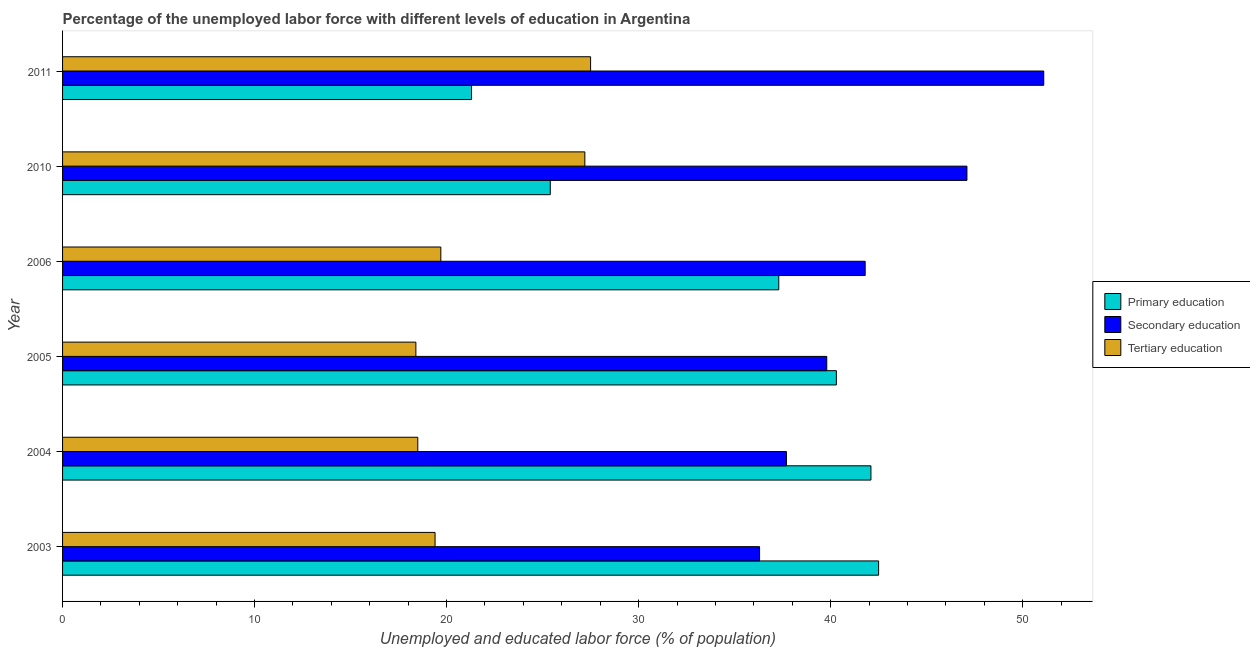How many different coloured bars are there?
Your answer should be very brief. 3. How many groups of bars are there?
Ensure brevity in your answer.  6. Are the number of bars per tick equal to the number of legend labels?
Provide a succinct answer. Yes. How many bars are there on the 5th tick from the top?
Offer a very short reply. 3. How many bars are there on the 3rd tick from the bottom?
Offer a terse response. 3. What is the label of the 4th group of bars from the top?
Make the answer very short. 2005. In how many cases, is the number of bars for a given year not equal to the number of legend labels?
Keep it short and to the point. 0. What is the percentage of labor force who received secondary education in 2005?
Your response must be concise. 39.8. Across all years, what is the maximum percentage of labor force who received secondary education?
Keep it short and to the point. 51.1. Across all years, what is the minimum percentage of labor force who received primary education?
Your response must be concise. 21.3. In which year was the percentage of labor force who received tertiary education maximum?
Ensure brevity in your answer.  2011. What is the total percentage of labor force who received tertiary education in the graph?
Your answer should be compact. 130.7. What is the difference between the percentage of labor force who received primary education in 2010 and that in 2011?
Your answer should be compact. 4.1. What is the difference between the percentage of labor force who received tertiary education in 2011 and the percentage of labor force who received secondary education in 2010?
Offer a terse response. -19.6. What is the average percentage of labor force who received primary education per year?
Your answer should be compact. 34.82. In the year 2005, what is the difference between the percentage of labor force who received primary education and percentage of labor force who received tertiary education?
Offer a terse response. 21.9. What is the ratio of the percentage of labor force who received primary education in 2004 to that in 2006?
Offer a very short reply. 1.13. Is the difference between the percentage of labor force who received secondary education in 2003 and 2004 greater than the difference between the percentage of labor force who received primary education in 2003 and 2004?
Ensure brevity in your answer.  No. What does the 2nd bar from the bottom in 2010 represents?
Your response must be concise. Secondary education. How many bars are there?
Provide a short and direct response. 18. Are all the bars in the graph horizontal?
Make the answer very short. Yes. What is the difference between two consecutive major ticks on the X-axis?
Provide a short and direct response. 10. Are the values on the major ticks of X-axis written in scientific E-notation?
Offer a very short reply. No. Does the graph contain grids?
Give a very brief answer. No. What is the title of the graph?
Make the answer very short. Percentage of the unemployed labor force with different levels of education in Argentina. What is the label or title of the X-axis?
Offer a terse response. Unemployed and educated labor force (% of population). What is the Unemployed and educated labor force (% of population) of Primary education in 2003?
Provide a succinct answer. 42.5. What is the Unemployed and educated labor force (% of population) in Secondary education in 2003?
Offer a terse response. 36.3. What is the Unemployed and educated labor force (% of population) in Tertiary education in 2003?
Give a very brief answer. 19.4. What is the Unemployed and educated labor force (% of population) of Primary education in 2004?
Your answer should be compact. 42.1. What is the Unemployed and educated labor force (% of population) of Secondary education in 2004?
Give a very brief answer. 37.7. What is the Unemployed and educated labor force (% of population) of Primary education in 2005?
Your answer should be compact. 40.3. What is the Unemployed and educated labor force (% of population) of Secondary education in 2005?
Give a very brief answer. 39.8. What is the Unemployed and educated labor force (% of population) of Tertiary education in 2005?
Your response must be concise. 18.4. What is the Unemployed and educated labor force (% of population) in Primary education in 2006?
Offer a very short reply. 37.3. What is the Unemployed and educated labor force (% of population) of Secondary education in 2006?
Your answer should be very brief. 41.8. What is the Unemployed and educated labor force (% of population) of Tertiary education in 2006?
Provide a succinct answer. 19.7. What is the Unemployed and educated labor force (% of population) in Primary education in 2010?
Offer a very short reply. 25.4. What is the Unemployed and educated labor force (% of population) of Secondary education in 2010?
Make the answer very short. 47.1. What is the Unemployed and educated labor force (% of population) in Tertiary education in 2010?
Your response must be concise. 27.2. What is the Unemployed and educated labor force (% of population) in Primary education in 2011?
Your answer should be very brief. 21.3. What is the Unemployed and educated labor force (% of population) in Secondary education in 2011?
Make the answer very short. 51.1. Across all years, what is the maximum Unemployed and educated labor force (% of population) in Primary education?
Give a very brief answer. 42.5. Across all years, what is the maximum Unemployed and educated labor force (% of population) of Secondary education?
Your answer should be very brief. 51.1. Across all years, what is the minimum Unemployed and educated labor force (% of population) of Primary education?
Your response must be concise. 21.3. Across all years, what is the minimum Unemployed and educated labor force (% of population) in Secondary education?
Offer a terse response. 36.3. Across all years, what is the minimum Unemployed and educated labor force (% of population) in Tertiary education?
Make the answer very short. 18.4. What is the total Unemployed and educated labor force (% of population) of Primary education in the graph?
Keep it short and to the point. 208.9. What is the total Unemployed and educated labor force (% of population) in Secondary education in the graph?
Your answer should be very brief. 253.8. What is the total Unemployed and educated labor force (% of population) of Tertiary education in the graph?
Ensure brevity in your answer.  130.7. What is the difference between the Unemployed and educated labor force (% of population) of Primary education in 2003 and that in 2004?
Your response must be concise. 0.4. What is the difference between the Unemployed and educated labor force (% of population) of Secondary education in 2003 and that in 2004?
Keep it short and to the point. -1.4. What is the difference between the Unemployed and educated labor force (% of population) in Primary education in 2003 and that in 2005?
Ensure brevity in your answer.  2.2. What is the difference between the Unemployed and educated labor force (% of population) of Secondary education in 2003 and that in 2005?
Make the answer very short. -3.5. What is the difference between the Unemployed and educated labor force (% of population) in Tertiary education in 2003 and that in 2005?
Offer a very short reply. 1. What is the difference between the Unemployed and educated labor force (% of population) in Primary education in 2003 and that in 2006?
Your answer should be compact. 5.2. What is the difference between the Unemployed and educated labor force (% of population) in Secondary education in 2003 and that in 2006?
Ensure brevity in your answer.  -5.5. What is the difference between the Unemployed and educated labor force (% of population) of Secondary education in 2003 and that in 2010?
Your answer should be very brief. -10.8. What is the difference between the Unemployed and educated labor force (% of population) in Tertiary education in 2003 and that in 2010?
Make the answer very short. -7.8. What is the difference between the Unemployed and educated labor force (% of population) in Primary education in 2003 and that in 2011?
Provide a succinct answer. 21.2. What is the difference between the Unemployed and educated labor force (% of population) in Secondary education in 2003 and that in 2011?
Your answer should be compact. -14.8. What is the difference between the Unemployed and educated labor force (% of population) in Tertiary education in 2003 and that in 2011?
Your response must be concise. -8.1. What is the difference between the Unemployed and educated labor force (% of population) in Secondary education in 2004 and that in 2005?
Keep it short and to the point. -2.1. What is the difference between the Unemployed and educated labor force (% of population) in Tertiary education in 2004 and that in 2006?
Give a very brief answer. -1.2. What is the difference between the Unemployed and educated labor force (% of population) of Primary education in 2004 and that in 2011?
Ensure brevity in your answer.  20.8. What is the difference between the Unemployed and educated labor force (% of population) of Primary education in 2005 and that in 2006?
Give a very brief answer. 3. What is the difference between the Unemployed and educated labor force (% of population) in Secondary education in 2005 and that in 2006?
Make the answer very short. -2. What is the difference between the Unemployed and educated labor force (% of population) of Tertiary education in 2005 and that in 2010?
Provide a succinct answer. -8.8. What is the difference between the Unemployed and educated labor force (% of population) of Tertiary education in 2006 and that in 2010?
Keep it short and to the point. -7.5. What is the difference between the Unemployed and educated labor force (% of population) of Tertiary education in 2006 and that in 2011?
Provide a succinct answer. -7.8. What is the difference between the Unemployed and educated labor force (% of population) in Primary education in 2003 and the Unemployed and educated labor force (% of population) in Tertiary education in 2004?
Give a very brief answer. 24. What is the difference between the Unemployed and educated labor force (% of population) in Primary education in 2003 and the Unemployed and educated labor force (% of population) in Tertiary education in 2005?
Offer a terse response. 24.1. What is the difference between the Unemployed and educated labor force (% of population) of Secondary education in 2003 and the Unemployed and educated labor force (% of population) of Tertiary education in 2005?
Give a very brief answer. 17.9. What is the difference between the Unemployed and educated labor force (% of population) of Primary education in 2003 and the Unemployed and educated labor force (% of population) of Tertiary education in 2006?
Ensure brevity in your answer.  22.8. What is the difference between the Unemployed and educated labor force (% of population) in Secondary education in 2003 and the Unemployed and educated labor force (% of population) in Tertiary education in 2006?
Ensure brevity in your answer.  16.6. What is the difference between the Unemployed and educated labor force (% of population) of Primary education in 2003 and the Unemployed and educated labor force (% of population) of Secondary education in 2010?
Provide a short and direct response. -4.6. What is the difference between the Unemployed and educated labor force (% of population) in Primary education in 2003 and the Unemployed and educated labor force (% of population) in Tertiary education in 2010?
Your answer should be compact. 15.3. What is the difference between the Unemployed and educated labor force (% of population) of Secondary education in 2003 and the Unemployed and educated labor force (% of population) of Tertiary education in 2011?
Give a very brief answer. 8.8. What is the difference between the Unemployed and educated labor force (% of population) in Primary education in 2004 and the Unemployed and educated labor force (% of population) in Tertiary education in 2005?
Your answer should be very brief. 23.7. What is the difference between the Unemployed and educated labor force (% of population) in Secondary education in 2004 and the Unemployed and educated labor force (% of population) in Tertiary education in 2005?
Provide a short and direct response. 19.3. What is the difference between the Unemployed and educated labor force (% of population) in Primary education in 2004 and the Unemployed and educated labor force (% of population) in Secondary education in 2006?
Your answer should be very brief. 0.3. What is the difference between the Unemployed and educated labor force (% of population) in Primary education in 2004 and the Unemployed and educated labor force (% of population) in Tertiary education in 2006?
Provide a short and direct response. 22.4. What is the difference between the Unemployed and educated labor force (% of population) in Secondary education in 2004 and the Unemployed and educated labor force (% of population) in Tertiary education in 2006?
Offer a terse response. 18. What is the difference between the Unemployed and educated labor force (% of population) of Primary education in 2004 and the Unemployed and educated labor force (% of population) of Tertiary education in 2011?
Give a very brief answer. 14.6. What is the difference between the Unemployed and educated labor force (% of population) of Primary education in 2005 and the Unemployed and educated labor force (% of population) of Tertiary education in 2006?
Your answer should be very brief. 20.6. What is the difference between the Unemployed and educated labor force (% of population) in Secondary education in 2005 and the Unemployed and educated labor force (% of population) in Tertiary education in 2006?
Your response must be concise. 20.1. What is the difference between the Unemployed and educated labor force (% of population) of Primary education in 2005 and the Unemployed and educated labor force (% of population) of Secondary education in 2010?
Keep it short and to the point. -6.8. What is the difference between the Unemployed and educated labor force (% of population) in Secondary education in 2005 and the Unemployed and educated labor force (% of population) in Tertiary education in 2010?
Provide a succinct answer. 12.6. What is the difference between the Unemployed and educated labor force (% of population) in Primary education in 2005 and the Unemployed and educated labor force (% of population) in Secondary education in 2011?
Provide a short and direct response. -10.8. What is the difference between the Unemployed and educated labor force (% of population) of Primary education in 2005 and the Unemployed and educated labor force (% of population) of Tertiary education in 2011?
Ensure brevity in your answer.  12.8. What is the difference between the Unemployed and educated labor force (% of population) of Secondary education in 2005 and the Unemployed and educated labor force (% of population) of Tertiary education in 2011?
Your answer should be very brief. 12.3. What is the difference between the Unemployed and educated labor force (% of population) of Primary education in 2006 and the Unemployed and educated labor force (% of population) of Tertiary education in 2010?
Offer a very short reply. 10.1. What is the difference between the Unemployed and educated labor force (% of population) in Primary education in 2006 and the Unemployed and educated labor force (% of population) in Secondary education in 2011?
Your response must be concise. -13.8. What is the difference between the Unemployed and educated labor force (% of population) in Primary education in 2006 and the Unemployed and educated labor force (% of population) in Tertiary education in 2011?
Offer a very short reply. 9.8. What is the difference between the Unemployed and educated labor force (% of population) of Primary education in 2010 and the Unemployed and educated labor force (% of population) of Secondary education in 2011?
Make the answer very short. -25.7. What is the difference between the Unemployed and educated labor force (% of population) in Primary education in 2010 and the Unemployed and educated labor force (% of population) in Tertiary education in 2011?
Make the answer very short. -2.1. What is the difference between the Unemployed and educated labor force (% of population) in Secondary education in 2010 and the Unemployed and educated labor force (% of population) in Tertiary education in 2011?
Ensure brevity in your answer.  19.6. What is the average Unemployed and educated labor force (% of population) of Primary education per year?
Offer a terse response. 34.82. What is the average Unemployed and educated labor force (% of population) in Secondary education per year?
Offer a very short reply. 42.3. What is the average Unemployed and educated labor force (% of population) in Tertiary education per year?
Your answer should be very brief. 21.78. In the year 2003, what is the difference between the Unemployed and educated labor force (% of population) of Primary education and Unemployed and educated labor force (% of population) of Tertiary education?
Your answer should be compact. 23.1. In the year 2003, what is the difference between the Unemployed and educated labor force (% of population) of Secondary education and Unemployed and educated labor force (% of population) of Tertiary education?
Offer a very short reply. 16.9. In the year 2004, what is the difference between the Unemployed and educated labor force (% of population) in Primary education and Unemployed and educated labor force (% of population) in Secondary education?
Make the answer very short. 4.4. In the year 2004, what is the difference between the Unemployed and educated labor force (% of population) in Primary education and Unemployed and educated labor force (% of population) in Tertiary education?
Provide a succinct answer. 23.6. In the year 2005, what is the difference between the Unemployed and educated labor force (% of population) of Primary education and Unemployed and educated labor force (% of population) of Secondary education?
Keep it short and to the point. 0.5. In the year 2005, what is the difference between the Unemployed and educated labor force (% of population) in Primary education and Unemployed and educated labor force (% of population) in Tertiary education?
Ensure brevity in your answer.  21.9. In the year 2005, what is the difference between the Unemployed and educated labor force (% of population) in Secondary education and Unemployed and educated labor force (% of population) in Tertiary education?
Provide a short and direct response. 21.4. In the year 2006, what is the difference between the Unemployed and educated labor force (% of population) of Primary education and Unemployed and educated labor force (% of population) of Secondary education?
Keep it short and to the point. -4.5. In the year 2006, what is the difference between the Unemployed and educated labor force (% of population) of Secondary education and Unemployed and educated labor force (% of population) of Tertiary education?
Provide a short and direct response. 22.1. In the year 2010, what is the difference between the Unemployed and educated labor force (% of population) in Primary education and Unemployed and educated labor force (% of population) in Secondary education?
Your answer should be very brief. -21.7. In the year 2011, what is the difference between the Unemployed and educated labor force (% of population) of Primary education and Unemployed and educated labor force (% of population) of Secondary education?
Offer a terse response. -29.8. In the year 2011, what is the difference between the Unemployed and educated labor force (% of population) of Secondary education and Unemployed and educated labor force (% of population) of Tertiary education?
Provide a short and direct response. 23.6. What is the ratio of the Unemployed and educated labor force (% of population) in Primary education in 2003 to that in 2004?
Make the answer very short. 1.01. What is the ratio of the Unemployed and educated labor force (% of population) of Secondary education in 2003 to that in 2004?
Offer a terse response. 0.96. What is the ratio of the Unemployed and educated labor force (% of population) in Tertiary education in 2003 to that in 2004?
Make the answer very short. 1.05. What is the ratio of the Unemployed and educated labor force (% of population) of Primary education in 2003 to that in 2005?
Provide a succinct answer. 1.05. What is the ratio of the Unemployed and educated labor force (% of population) of Secondary education in 2003 to that in 2005?
Offer a terse response. 0.91. What is the ratio of the Unemployed and educated labor force (% of population) in Tertiary education in 2003 to that in 2005?
Make the answer very short. 1.05. What is the ratio of the Unemployed and educated labor force (% of population) in Primary education in 2003 to that in 2006?
Provide a succinct answer. 1.14. What is the ratio of the Unemployed and educated labor force (% of population) in Secondary education in 2003 to that in 2006?
Your answer should be compact. 0.87. What is the ratio of the Unemployed and educated labor force (% of population) in Tertiary education in 2003 to that in 2006?
Provide a short and direct response. 0.98. What is the ratio of the Unemployed and educated labor force (% of population) in Primary education in 2003 to that in 2010?
Offer a terse response. 1.67. What is the ratio of the Unemployed and educated labor force (% of population) in Secondary education in 2003 to that in 2010?
Your answer should be compact. 0.77. What is the ratio of the Unemployed and educated labor force (% of population) of Tertiary education in 2003 to that in 2010?
Offer a very short reply. 0.71. What is the ratio of the Unemployed and educated labor force (% of population) of Primary education in 2003 to that in 2011?
Offer a very short reply. 2. What is the ratio of the Unemployed and educated labor force (% of population) in Secondary education in 2003 to that in 2011?
Make the answer very short. 0.71. What is the ratio of the Unemployed and educated labor force (% of population) of Tertiary education in 2003 to that in 2011?
Give a very brief answer. 0.71. What is the ratio of the Unemployed and educated labor force (% of population) in Primary education in 2004 to that in 2005?
Ensure brevity in your answer.  1.04. What is the ratio of the Unemployed and educated labor force (% of population) in Secondary education in 2004 to that in 2005?
Offer a terse response. 0.95. What is the ratio of the Unemployed and educated labor force (% of population) of Tertiary education in 2004 to that in 2005?
Offer a very short reply. 1.01. What is the ratio of the Unemployed and educated labor force (% of population) in Primary education in 2004 to that in 2006?
Your response must be concise. 1.13. What is the ratio of the Unemployed and educated labor force (% of population) in Secondary education in 2004 to that in 2006?
Provide a succinct answer. 0.9. What is the ratio of the Unemployed and educated labor force (% of population) of Tertiary education in 2004 to that in 2006?
Your response must be concise. 0.94. What is the ratio of the Unemployed and educated labor force (% of population) of Primary education in 2004 to that in 2010?
Provide a succinct answer. 1.66. What is the ratio of the Unemployed and educated labor force (% of population) in Secondary education in 2004 to that in 2010?
Your answer should be very brief. 0.8. What is the ratio of the Unemployed and educated labor force (% of population) of Tertiary education in 2004 to that in 2010?
Give a very brief answer. 0.68. What is the ratio of the Unemployed and educated labor force (% of population) in Primary education in 2004 to that in 2011?
Offer a terse response. 1.98. What is the ratio of the Unemployed and educated labor force (% of population) of Secondary education in 2004 to that in 2011?
Give a very brief answer. 0.74. What is the ratio of the Unemployed and educated labor force (% of population) in Tertiary education in 2004 to that in 2011?
Keep it short and to the point. 0.67. What is the ratio of the Unemployed and educated labor force (% of population) in Primary education in 2005 to that in 2006?
Your answer should be very brief. 1.08. What is the ratio of the Unemployed and educated labor force (% of population) in Secondary education in 2005 to that in 2006?
Your answer should be compact. 0.95. What is the ratio of the Unemployed and educated labor force (% of population) in Tertiary education in 2005 to that in 2006?
Provide a short and direct response. 0.93. What is the ratio of the Unemployed and educated labor force (% of population) of Primary education in 2005 to that in 2010?
Keep it short and to the point. 1.59. What is the ratio of the Unemployed and educated labor force (% of population) in Secondary education in 2005 to that in 2010?
Your answer should be compact. 0.84. What is the ratio of the Unemployed and educated labor force (% of population) in Tertiary education in 2005 to that in 2010?
Give a very brief answer. 0.68. What is the ratio of the Unemployed and educated labor force (% of population) of Primary education in 2005 to that in 2011?
Offer a very short reply. 1.89. What is the ratio of the Unemployed and educated labor force (% of population) of Secondary education in 2005 to that in 2011?
Offer a very short reply. 0.78. What is the ratio of the Unemployed and educated labor force (% of population) in Tertiary education in 2005 to that in 2011?
Your answer should be compact. 0.67. What is the ratio of the Unemployed and educated labor force (% of population) of Primary education in 2006 to that in 2010?
Your response must be concise. 1.47. What is the ratio of the Unemployed and educated labor force (% of population) of Secondary education in 2006 to that in 2010?
Your response must be concise. 0.89. What is the ratio of the Unemployed and educated labor force (% of population) of Tertiary education in 2006 to that in 2010?
Your response must be concise. 0.72. What is the ratio of the Unemployed and educated labor force (% of population) of Primary education in 2006 to that in 2011?
Make the answer very short. 1.75. What is the ratio of the Unemployed and educated labor force (% of population) of Secondary education in 2006 to that in 2011?
Your answer should be compact. 0.82. What is the ratio of the Unemployed and educated labor force (% of population) in Tertiary education in 2006 to that in 2011?
Your response must be concise. 0.72. What is the ratio of the Unemployed and educated labor force (% of population) in Primary education in 2010 to that in 2011?
Offer a very short reply. 1.19. What is the ratio of the Unemployed and educated labor force (% of population) of Secondary education in 2010 to that in 2011?
Give a very brief answer. 0.92. What is the difference between the highest and the second highest Unemployed and educated labor force (% of population) of Primary education?
Ensure brevity in your answer.  0.4. What is the difference between the highest and the second highest Unemployed and educated labor force (% of population) of Secondary education?
Keep it short and to the point. 4. What is the difference between the highest and the second highest Unemployed and educated labor force (% of population) of Tertiary education?
Provide a short and direct response. 0.3. What is the difference between the highest and the lowest Unemployed and educated labor force (% of population) in Primary education?
Offer a very short reply. 21.2. What is the difference between the highest and the lowest Unemployed and educated labor force (% of population) of Secondary education?
Keep it short and to the point. 14.8. 